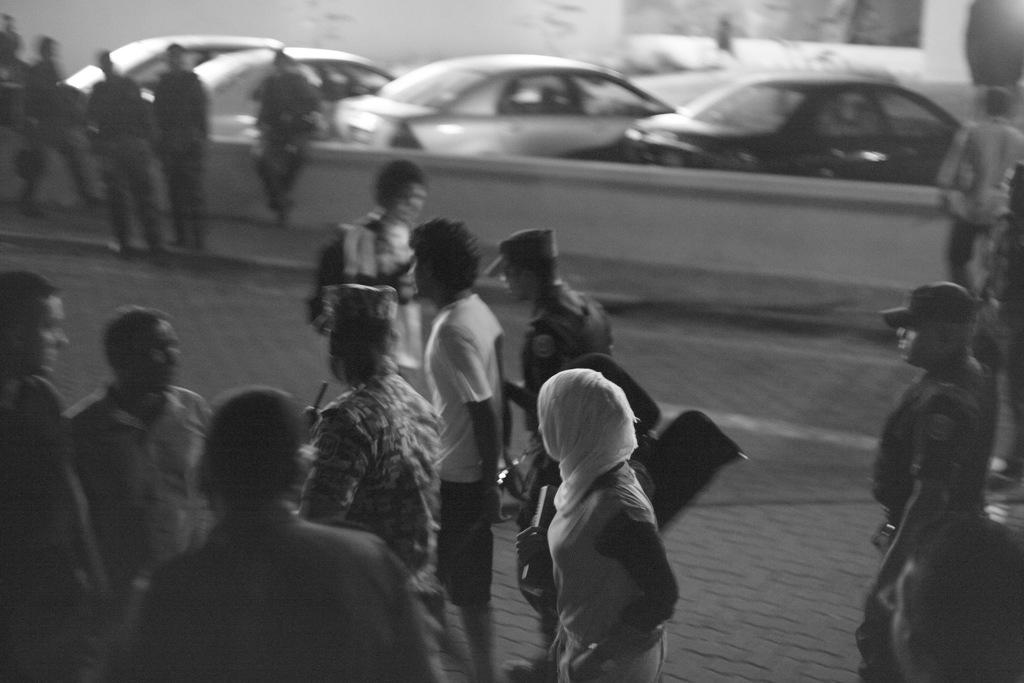Who or what can be seen in the image? There are people and cars in the image. What is the background of the image? There is a wall in the image. How many lizards are sitting on the cars in the image? There are no lizards present in the image. What type of cup can be seen in the hands of the people in the image? There is no cup visible in the hands of the people in the image. 